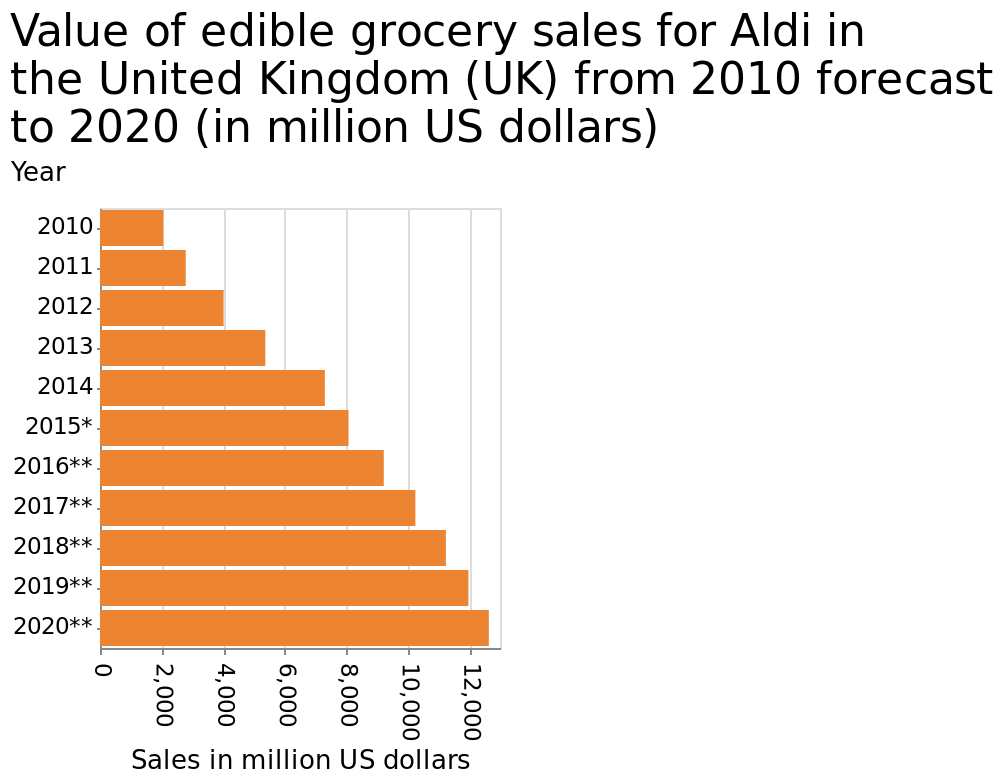<image>
What is the range of the x-axis in the bar plot?  The range of the x-axis in the bar plot is from 0 to 12,000 million US dollars. Offer a thorough analysis of the image. Sales have increased every year, since 2010, by similar amounts. 